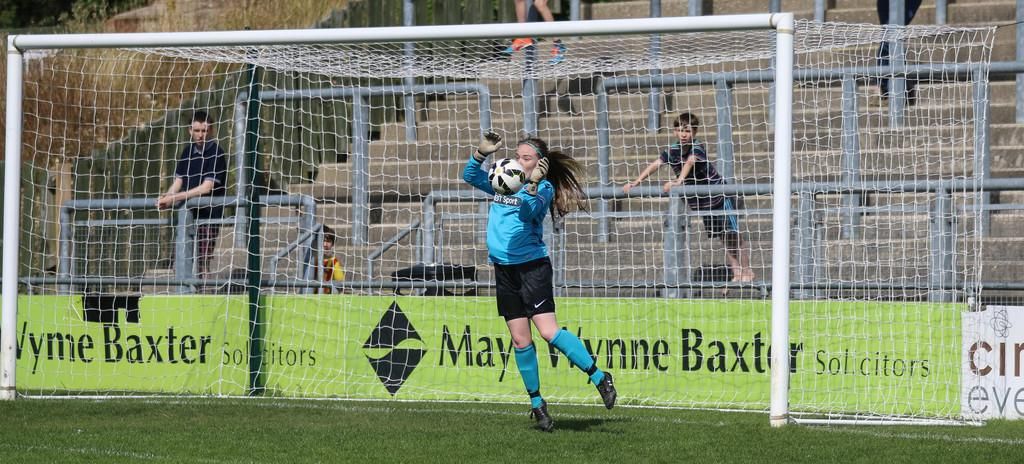<image>
Share a concise interpretation of the image provided. the word Baxter is on the sign behind the goalie 